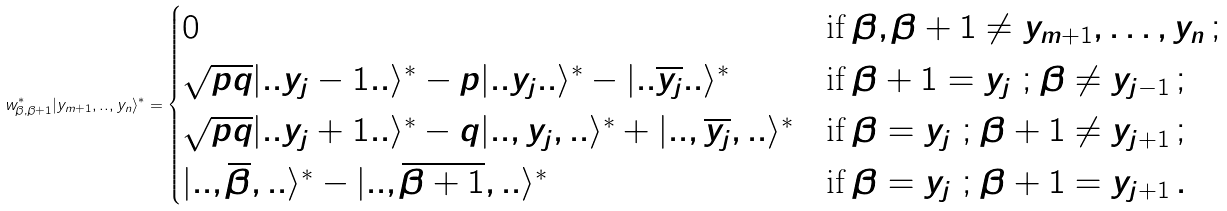Convert formula to latex. <formula><loc_0><loc_0><loc_500><loc_500>w _ { \beta , \beta + 1 } ^ { * } | y _ { m + 1 } , . . , y _ { n } \rangle ^ { * } = \begin{cases} 0 & \text {if } \beta , \beta + 1 \neq y _ { m + 1 } , \dots , y _ { n } \, ; \\ \sqrt { p q } | . . y _ { j } - 1 . . \rangle ^ { * } - p | . . y _ { j } . . \rangle ^ { * } - | . . \overline { y _ { j } } . . \rangle ^ { * } & \text {if } \beta + 1 = y _ { j } \ ; \, \beta \neq y _ { j - 1 } \, ; \\ \sqrt { p q } | . . y _ { j } + 1 . . \rangle ^ { * } - q | . . , y _ { j } , . . \rangle ^ { * } + | . . , \overline { y _ { j } } , . . \rangle ^ { * } & \text {if } \beta = y _ { j } \ ; \, \beta + 1 \neq y _ { j + 1 } \, ; \\ | . . , \overline { \beta } , . . \rangle ^ { * } - | . . , \overline { \beta + 1 } , . . \rangle ^ { * } & \text {if } \beta = y _ { j } \ ; \, \beta + 1 = y _ { j + 1 } \, . \end{cases}</formula> 